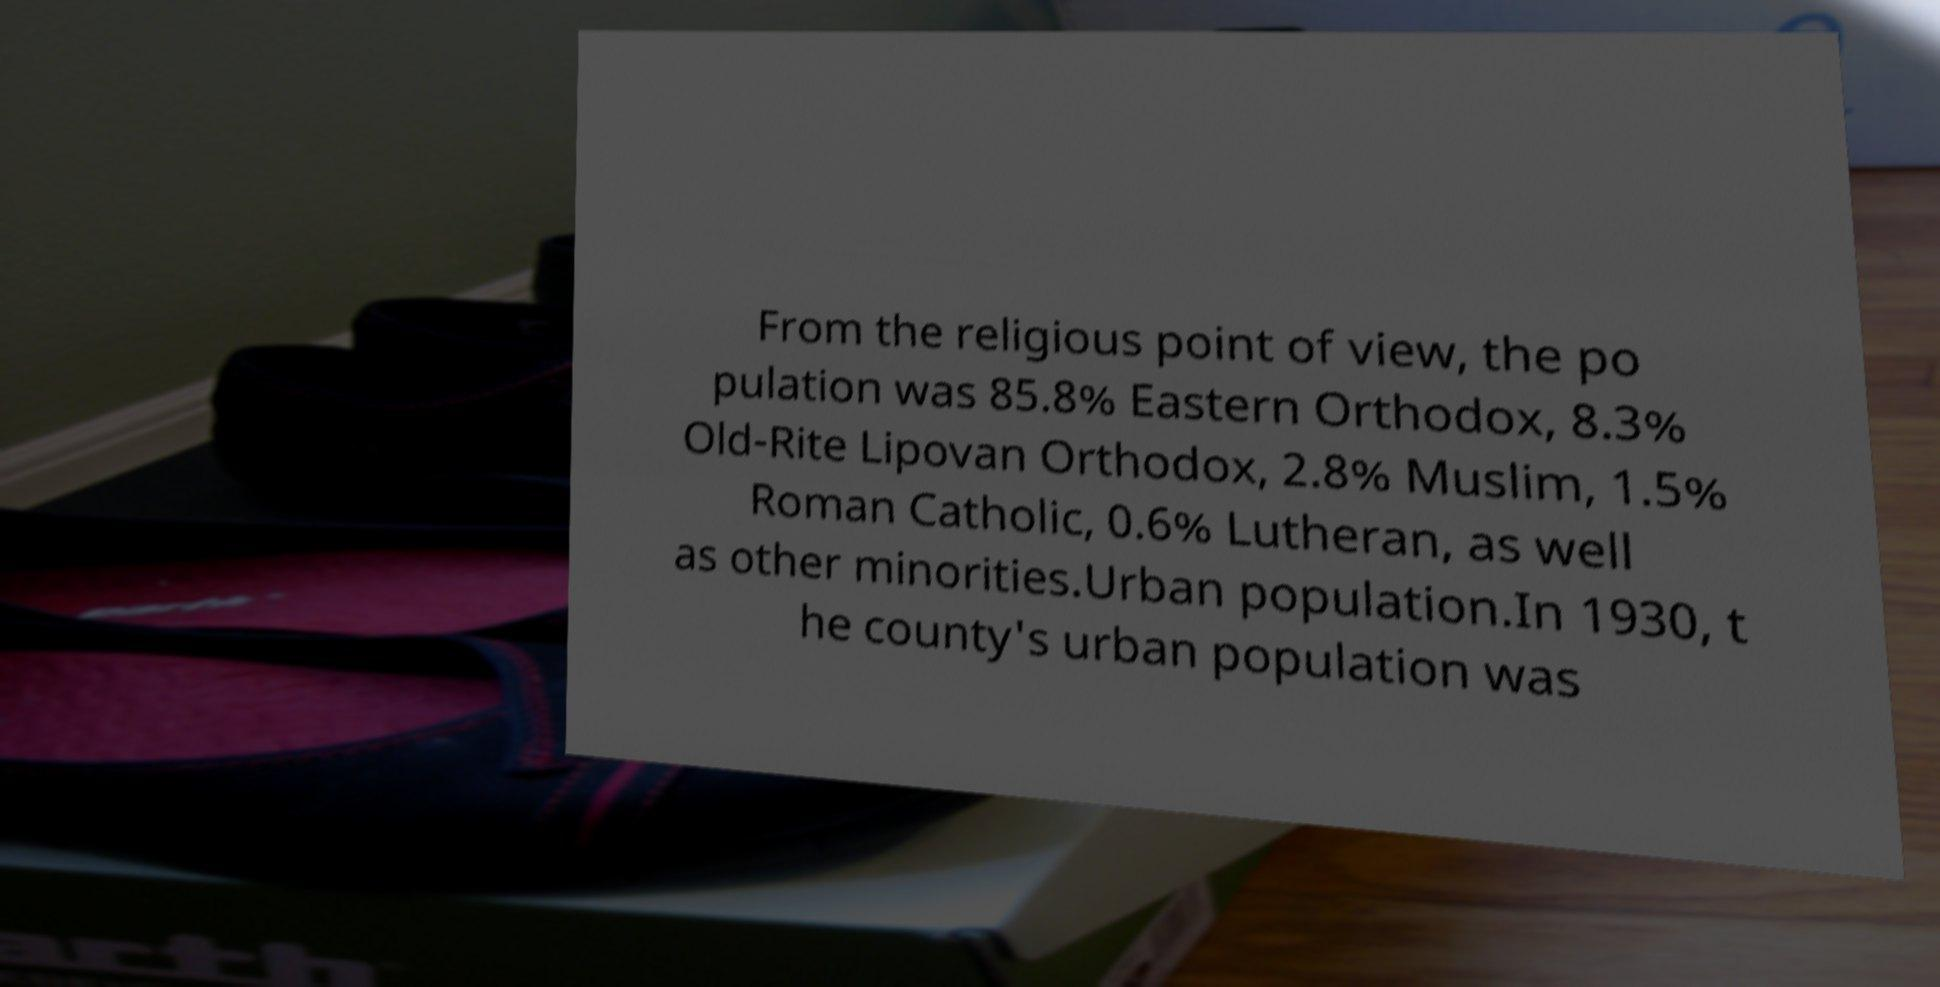What messages or text are displayed in this image? I need them in a readable, typed format. From the religious point of view, the po pulation was 85.8% Eastern Orthodox, 8.3% Old-Rite Lipovan Orthodox, 2.8% Muslim, 1.5% Roman Catholic, 0.6% Lutheran, as well as other minorities.Urban population.In 1930, t he county's urban population was 